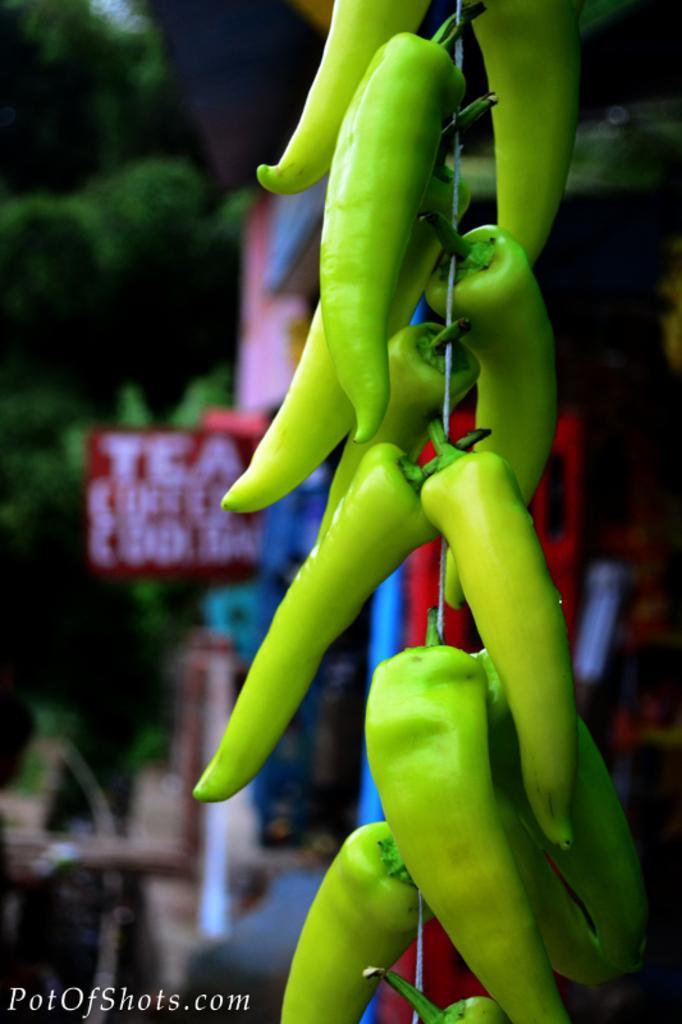Could you give a brief overview of what you see in this image? We can see green chillies with wire. In the background it is blurry and we can see red board and trees. In the bottom left of the image we can see text. 